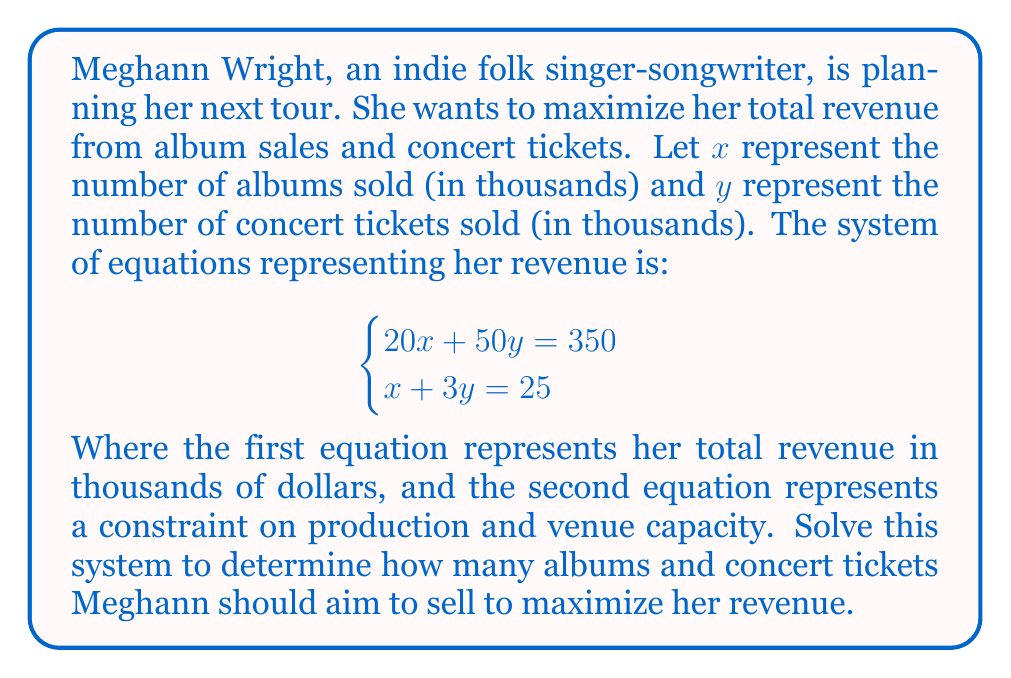Teach me how to tackle this problem. Let's solve this system of equations using the substitution method:

1) From the second equation, we can express $x$ in terms of $y$:
   $x + 3y = 25$
   $x = 25 - 3y$

2) Substitute this expression for $x$ into the first equation:
   $20(25 - 3y) + 50y = 350$

3) Simplify:
   $500 - 60y + 50y = 350$
   $500 - 10y = 350$

4) Solve for $y$:
   $-10y = -150$
   $y = 15$

5) Now that we know $y$, substitute back into the equation from step 1 to find $x$:
   $x = 25 - 3(15) = 25 - 45 = -20$

6) However, since $x$ represents thousands of albums sold, it can't be negative. This means our solution is at the boundary of our feasible region.

7) Let's solve again using $y = 8.333$ (rounded to 3 decimal places):
   $x = 25 - 3(8.333) = 0$

Therefore, the optimal solution is approximately:
$x = 0$ and $y = 8.333$
Answer: $x \approx 0$, $y \approx 8.333$ (thousand) 